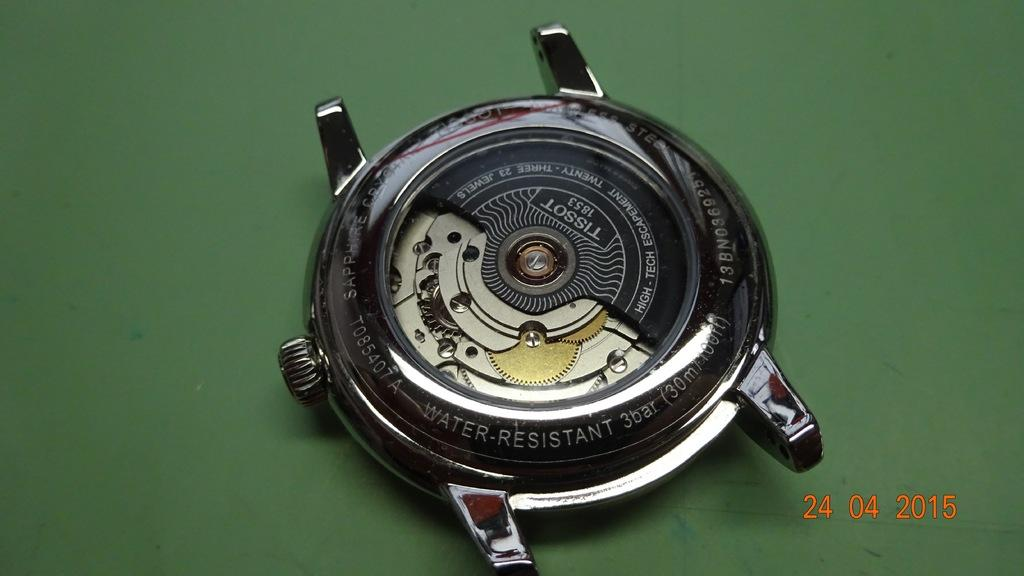<image>
Relay a brief, clear account of the picture shown. the number 24 is next to the large silver item 